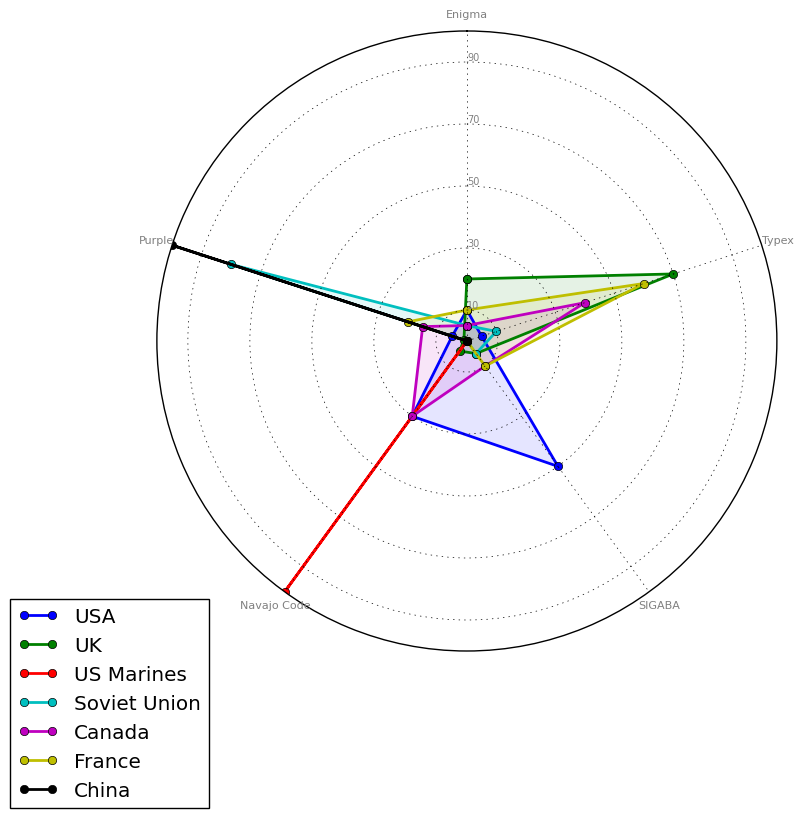What percentage of usage does the UK have for Typex and how does it compare to France's usage? Check the percentages for the UK and France under Typex. The UK has 70% while France has 60%. The UK uses Typex 10% more than France.
Answer: 10% Which allied force has the highest usage of the Navajo Code? Analyze the segment for Navajo Code. The US Marines have 100%, which is the highest.
Answer: US Marines Among USA, UK, and Canada, which has the least usage of Enigma, and what is the difference between this value and the highest usage among these three countries? Compare the Enigma percentages for USA (10%), UK (20%), and Canada (5%). Canada has the least with 5%, and the highest value is the UK's 20%. The difference is 15%.
Answer: Canada, 15% Looking at the Soviet Union's data, what is the total percentage usage for Enigma and Purple combined? Add the percentages for Enigma (5%) and Purple (80%) for the Soviet Union. 5% + 80% = 85%.
Answer: 85% Which cipher type is exclusively used by China, and what is its percentage? Check the data for China. Only Purple is used with a percentage of 100%.
Answer: Purple, 100% Does any allied force have a zero usage percentage for all cipher types except one? If so, which force and what cipher? Check for zeroes across all cipher types per force. US Marines have 0% for all cipher types except Navajo Code, which is 100%.
Answer: US Marines, Navajo Code How many allied forces utilize the Purple cipher and what is the average percentage usage among them? Count the forces using Purple (USA, Soviet Union, Canada, France, China - 5 forces) and average their percentages (5 + 80 + 15 + 20 + 100) / 5 = 44%.
Answer: 5, 44% Compare the percentage usage of SIGABA between USA and UK. Which one is higher and by how much? Check the percentage for SIGABA. USA has 50% while UK has 5%. USA’s usage is 45% higher.
Answer: USA, 45% For the USA, what is the combined percentage usage for all cipher types other than SIGABA? Sum the percentages for USA excluding SIGABA: 10% (Enigma) + 5% (Typex) + 30% (Navajo Code) + 5% (Purple) = 50%.
Answer: 50% What is the difference in Typex usage between France and Canada? Compare the percentage of Typex between France (60%) and Canada (40%). Difference is 20%.
Answer: 20% 